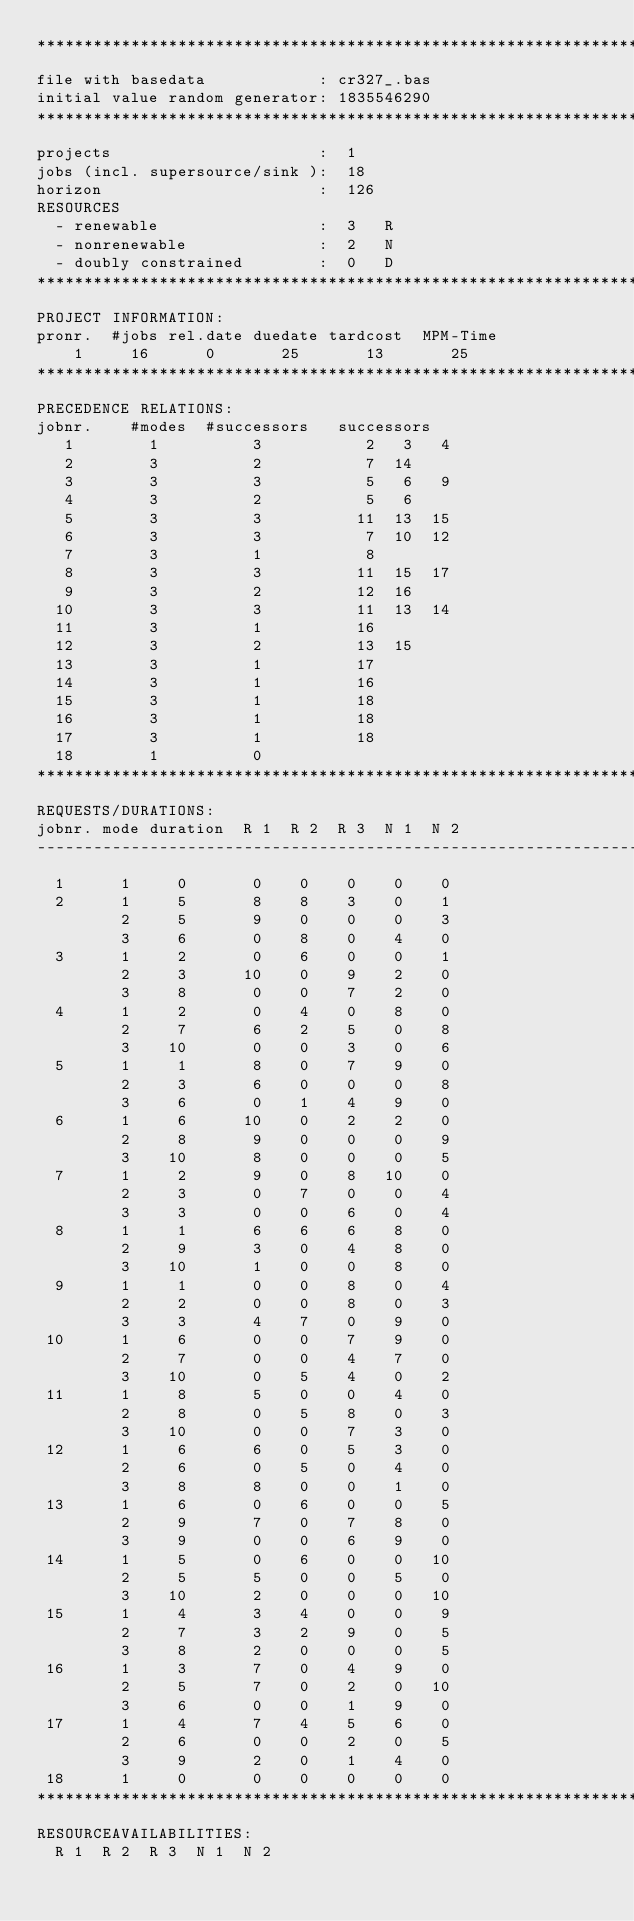Convert code to text. <code><loc_0><loc_0><loc_500><loc_500><_ObjectiveC_>************************************************************************
file with basedata            : cr327_.bas
initial value random generator: 1835546290
************************************************************************
projects                      :  1
jobs (incl. supersource/sink ):  18
horizon                       :  126
RESOURCES
  - renewable                 :  3   R
  - nonrenewable              :  2   N
  - doubly constrained        :  0   D
************************************************************************
PROJECT INFORMATION:
pronr.  #jobs rel.date duedate tardcost  MPM-Time
    1     16      0       25       13       25
************************************************************************
PRECEDENCE RELATIONS:
jobnr.    #modes  #successors   successors
   1        1          3           2   3   4
   2        3          2           7  14
   3        3          3           5   6   9
   4        3          2           5   6
   5        3          3          11  13  15
   6        3          3           7  10  12
   7        3          1           8
   8        3          3          11  15  17
   9        3          2          12  16
  10        3          3          11  13  14
  11        3          1          16
  12        3          2          13  15
  13        3          1          17
  14        3          1          16
  15        3          1          18
  16        3          1          18
  17        3          1          18
  18        1          0        
************************************************************************
REQUESTS/DURATIONS:
jobnr. mode duration  R 1  R 2  R 3  N 1  N 2
------------------------------------------------------------------------
  1      1     0       0    0    0    0    0
  2      1     5       8    8    3    0    1
         2     5       9    0    0    0    3
         3     6       0    8    0    4    0
  3      1     2       0    6    0    0    1
         2     3      10    0    9    2    0
         3     8       0    0    7    2    0
  4      1     2       0    4    0    8    0
         2     7       6    2    5    0    8
         3    10       0    0    3    0    6
  5      1     1       8    0    7    9    0
         2     3       6    0    0    0    8
         3     6       0    1    4    9    0
  6      1     6      10    0    2    2    0
         2     8       9    0    0    0    9
         3    10       8    0    0    0    5
  7      1     2       9    0    8   10    0
         2     3       0    7    0    0    4
         3     3       0    0    6    0    4
  8      1     1       6    6    6    8    0
         2     9       3    0    4    8    0
         3    10       1    0    0    8    0
  9      1     1       0    0    8    0    4
         2     2       0    0    8    0    3
         3     3       4    7    0    9    0
 10      1     6       0    0    7    9    0
         2     7       0    0    4    7    0
         3    10       0    5    4    0    2
 11      1     8       5    0    0    4    0
         2     8       0    5    8    0    3
         3    10       0    0    7    3    0
 12      1     6       6    0    5    3    0
         2     6       0    5    0    4    0
         3     8       8    0    0    1    0
 13      1     6       0    6    0    0    5
         2     9       7    0    7    8    0
         3     9       0    0    6    9    0
 14      1     5       0    6    0    0   10
         2     5       5    0    0    5    0
         3    10       2    0    0    0   10
 15      1     4       3    4    0    0    9
         2     7       3    2    9    0    5
         3     8       2    0    0    0    5
 16      1     3       7    0    4    9    0
         2     5       7    0    2    0   10
         3     6       0    0    1    9    0
 17      1     4       7    4    5    6    0
         2     6       0    0    2    0    5
         3     9       2    0    1    4    0
 18      1     0       0    0    0    0    0
************************************************************************
RESOURCEAVAILABILITIES:
  R 1  R 2  R 3  N 1  N 2</code> 